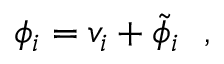<formula> <loc_0><loc_0><loc_500><loc_500>\phi _ { i } = v _ { i } + \tilde { \phi } _ { i } ,</formula> 